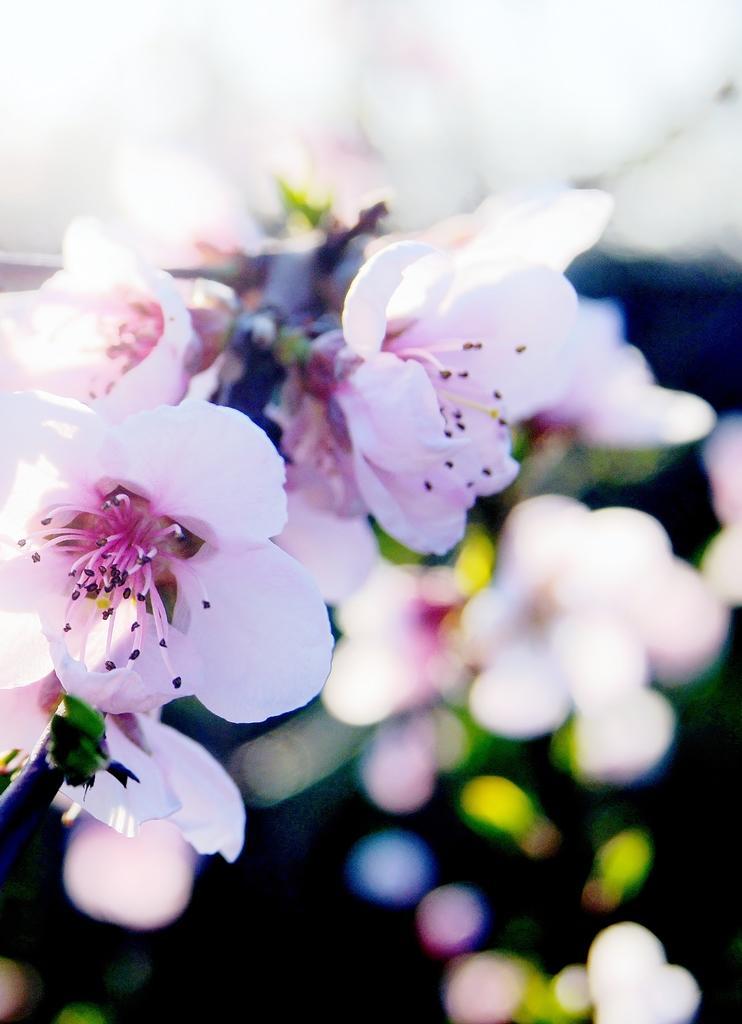Could you give a brief overview of what you see in this image? In this image in the front there are flowers and the background is blurry. 